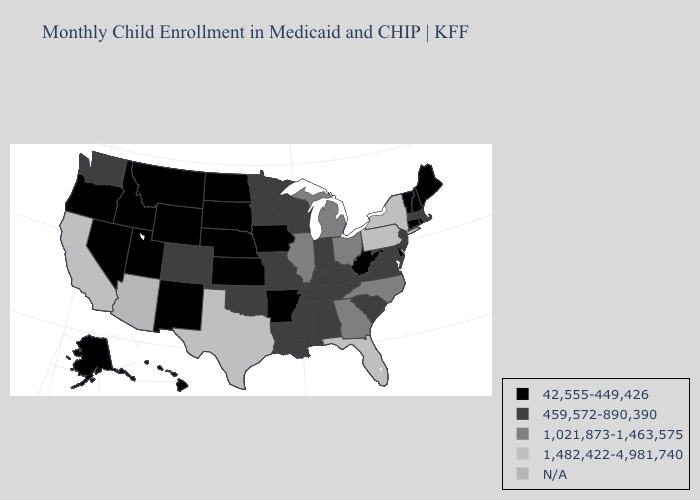What is the value of Massachusetts?
Be succinct. 459,572-890,390. Name the states that have a value in the range 1,021,873-1,463,575?
Be succinct. Georgia, Illinois, Michigan, North Carolina, Ohio. Name the states that have a value in the range 1,021,873-1,463,575?
Short answer required. Georgia, Illinois, Michigan, North Carolina, Ohio. Among the states that border Kansas , does Nebraska have the highest value?
Quick response, please. No. What is the lowest value in the USA?
Quick response, please. 42,555-449,426. What is the value of California?
Quick response, please. 1,482,422-4,981,740. What is the value of Oregon?
Be succinct. 42,555-449,426. Does Texas have the highest value in the South?
Keep it brief. Yes. Name the states that have a value in the range 459,572-890,390?
Quick response, please. Alabama, Colorado, Indiana, Kentucky, Louisiana, Maryland, Massachusetts, Minnesota, Mississippi, Missouri, New Jersey, Oklahoma, South Carolina, Tennessee, Virginia, Washington, Wisconsin. Name the states that have a value in the range 459,572-890,390?
Give a very brief answer. Alabama, Colorado, Indiana, Kentucky, Louisiana, Maryland, Massachusetts, Minnesota, Mississippi, Missouri, New Jersey, Oklahoma, South Carolina, Tennessee, Virginia, Washington, Wisconsin. Name the states that have a value in the range N/A?
Short answer required. Arizona. Does the first symbol in the legend represent the smallest category?
Quick response, please. Yes. Which states have the lowest value in the South?
Write a very short answer. Arkansas, Delaware, West Virginia. 